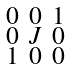<formula> <loc_0><loc_0><loc_500><loc_500>\begin{smallmatrix} 0 & 0 & 1 \\ 0 & J & 0 \\ 1 & 0 & 0 \end{smallmatrix}</formula> 